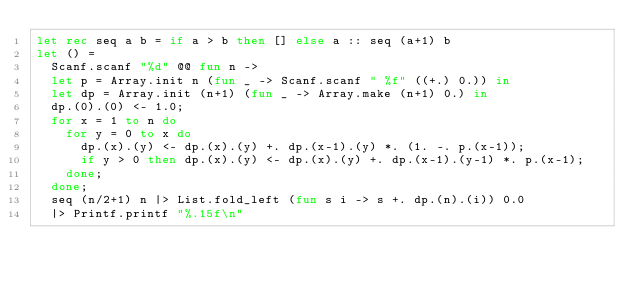Convert code to text. <code><loc_0><loc_0><loc_500><loc_500><_OCaml_>let rec seq a b = if a > b then [] else a :: seq (a+1) b
let () =
  Scanf.scanf "%d" @@ fun n ->
  let p = Array.init n (fun _ -> Scanf.scanf " %f" ((+.) 0.)) in
  let dp = Array.init (n+1) (fun _ -> Array.make (n+1) 0.) in
  dp.(0).(0) <- 1.0;
  for x = 1 to n do
    for y = 0 to x do
      dp.(x).(y) <- dp.(x).(y) +. dp.(x-1).(y) *. (1. -. p.(x-1));
      if y > 0 then dp.(x).(y) <- dp.(x).(y) +. dp.(x-1).(y-1) *. p.(x-1);
    done;
  done;
  seq (n/2+1) n |> List.fold_left (fun s i -> s +. dp.(n).(i)) 0.0
  |> Printf.printf "%.15f\n"</code> 